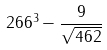<formula> <loc_0><loc_0><loc_500><loc_500>2 6 6 ^ { 3 } - \frac { 9 } { \sqrt { 4 6 2 } }</formula> 